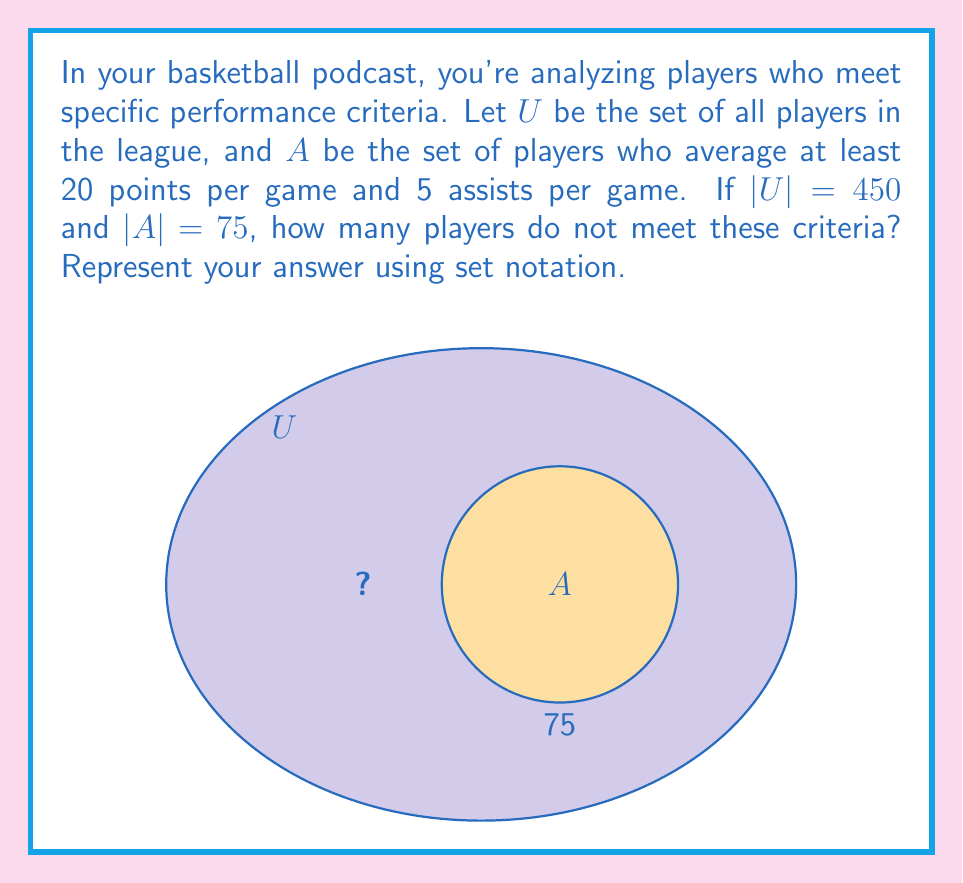What is the answer to this math problem? Let's approach this step-by-step:

1) We're looking for the complement of set $A$, which we can denote as $A^c$.

2) The complement of a set contains all elements in the universal set that are not in the given set.

3) In set theory, we can express this as:
   $A^c = U \setminus A$

4) The number of elements in the complement is the difference between the number of elements in the universal set and the given set:
   $|A^c| = |U| - |A|$

5) We're given:
   $|U| = 450$ (total number of players in the league)
   $|A| = 75$ (number of players meeting the criteria)

6) Substituting these values:
   $|A^c| = 450 - 75 = 375$

7) Therefore, 375 players do not meet the criteria of averaging at least 20 points and 5 assists per game.

8) In set notation, we represent this as:
   $|U \setminus A| = 375$
Answer: $|U \setminus A| = 375$ 